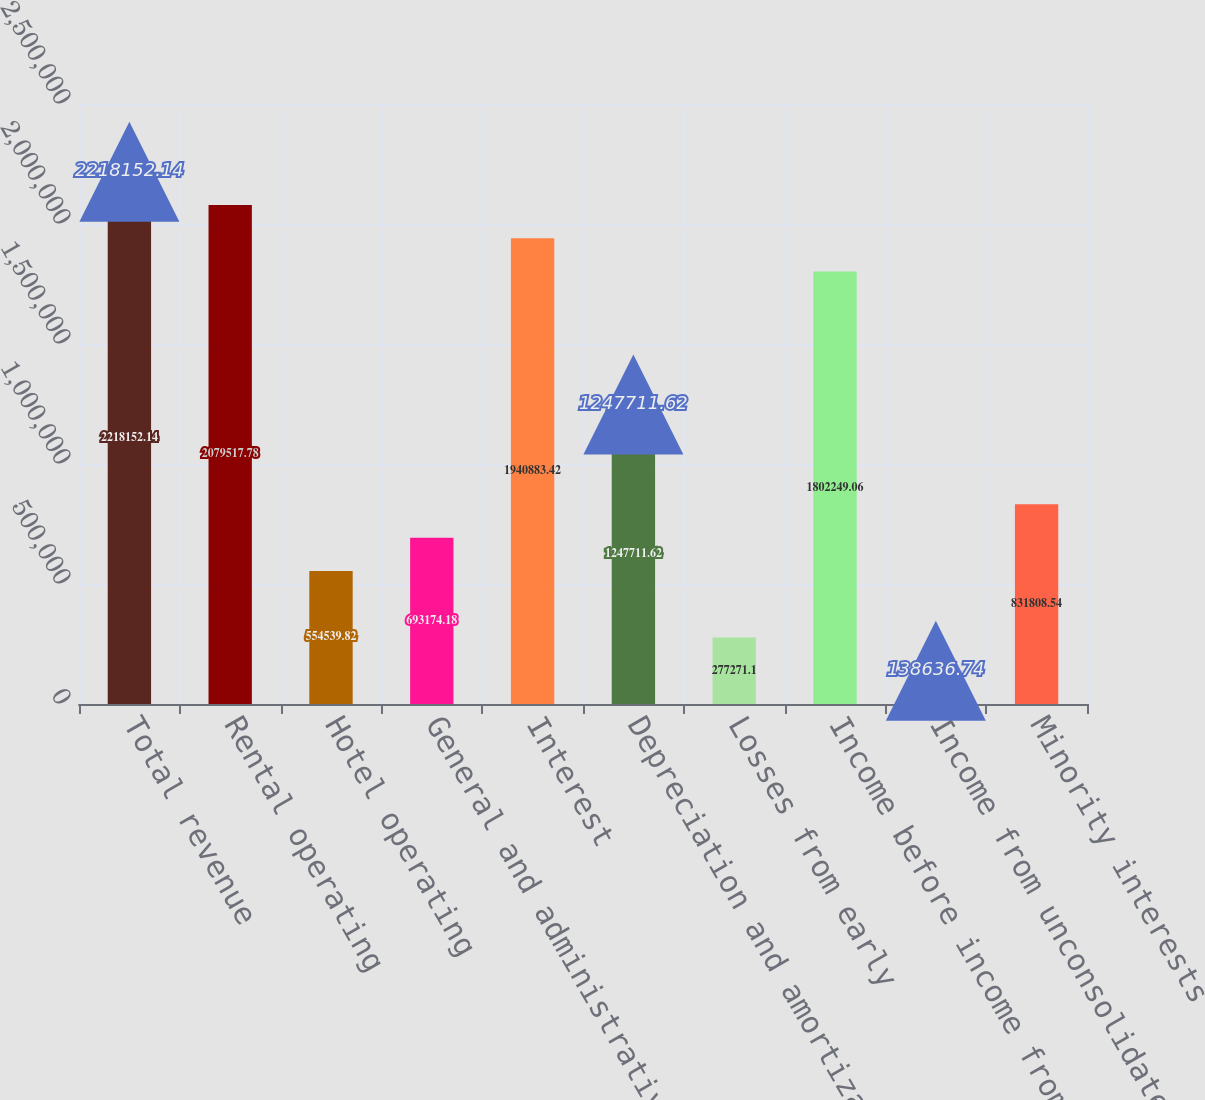Convert chart to OTSL. <chart><loc_0><loc_0><loc_500><loc_500><bar_chart><fcel>Total revenue<fcel>Rental operating<fcel>Hotel operating<fcel>General and administrative<fcel>Interest<fcel>Depreciation and amortization<fcel>Losses from early<fcel>Income before income from<fcel>Income from unconsolidated<fcel>Minority interests<nl><fcel>2.21815e+06<fcel>2.07952e+06<fcel>554540<fcel>693174<fcel>1.94088e+06<fcel>1.24771e+06<fcel>277271<fcel>1.80225e+06<fcel>138637<fcel>831809<nl></chart> 